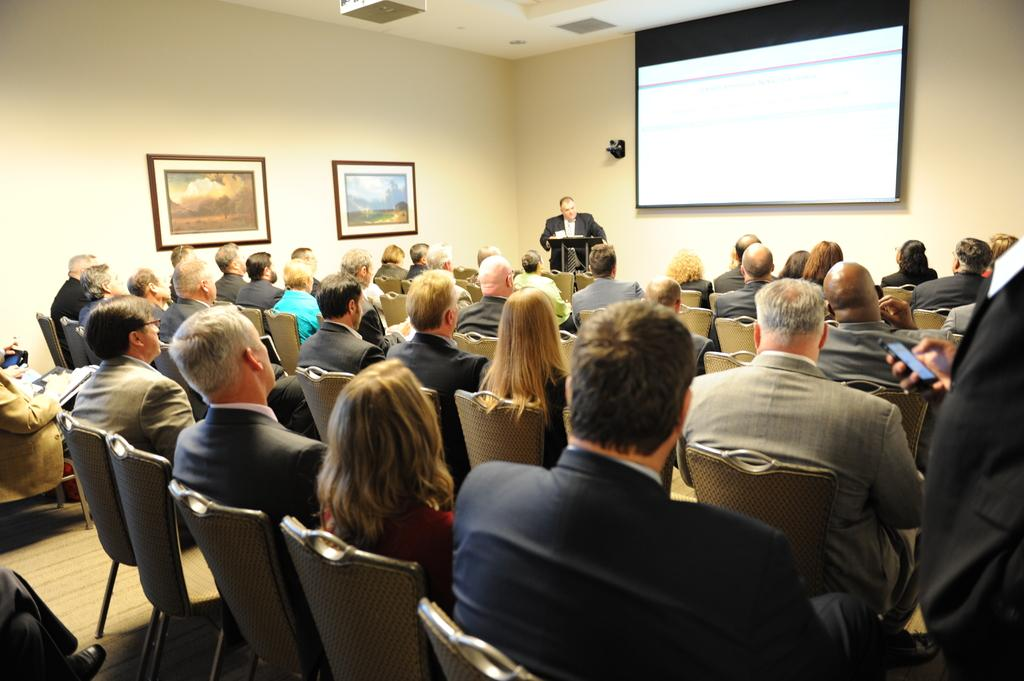What are the people in the image doing? There is a group of people sitting on chairs. What is the man in the image doing? A man is standing and speaking. What can be seen on the right side of the image? There is a projector screen on the right side. What type of plantation is visible in the image? There is no plantation present in the image. Can you tell me who the father of the man speaking is? There is no information about the man's father in the image. 